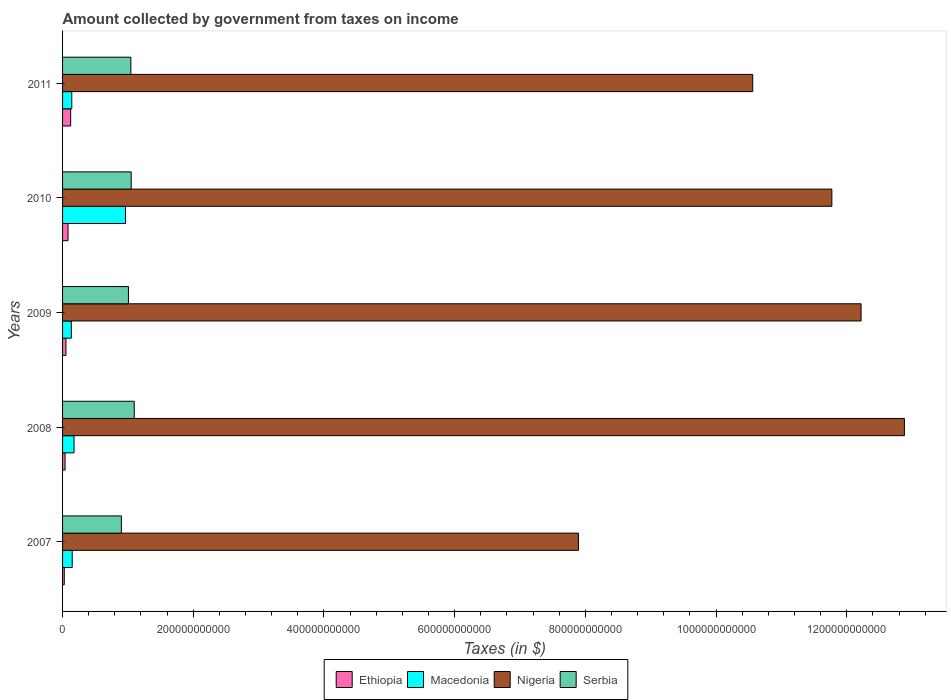How many different coloured bars are there?
Provide a succinct answer. 4. Are the number of bars per tick equal to the number of legend labels?
Your answer should be compact. Yes. How many bars are there on the 3rd tick from the top?
Your answer should be very brief. 4. How many bars are there on the 4th tick from the bottom?
Give a very brief answer. 4. What is the label of the 5th group of bars from the top?
Offer a terse response. 2007. What is the amount collected by government from taxes on income in Macedonia in 2008?
Offer a terse response. 1.76e+1. Across all years, what is the maximum amount collected by government from taxes on income in Macedonia?
Ensure brevity in your answer.  9.63e+1. Across all years, what is the minimum amount collected by government from taxes on income in Macedonia?
Your response must be concise. 1.34e+1. In which year was the amount collected by government from taxes on income in Nigeria maximum?
Your answer should be compact. 2008. In which year was the amount collected by government from taxes on income in Nigeria minimum?
Your response must be concise. 2007. What is the total amount collected by government from taxes on income in Ethiopia in the graph?
Your answer should be very brief. 3.24e+1. What is the difference between the amount collected by government from taxes on income in Nigeria in 2008 and that in 2011?
Make the answer very short. 2.32e+11. What is the difference between the amount collected by government from taxes on income in Macedonia in 2009 and the amount collected by government from taxes on income in Ethiopia in 2008?
Keep it short and to the point. 9.61e+09. What is the average amount collected by government from taxes on income in Nigeria per year?
Your answer should be compact. 1.11e+12. In the year 2010, what is the difference between the amount collected by government from taxes on income in Ethiopia and amount collected by government from taxes on income in Serbia?
Give a very brief answer. -9.67e+1. In how many years, is the amount collected by government from taxes on income in Serbia greater than 920000000000 $?
Ensure brevity in your answer.  0. What is the ratio of the amount collected by government from taxes on income in Macedonia in 2008 to that in 2011?
Offer a very short reply. 1.25. Is the difference between the amount collected by government from taxes on income in Ethiopia in 2009 and 2011 greater than the difference between the amount collected by government from taxes on income in Serbia in 2009 and 2011?
Ensure brevity in your answer.  No. What is the difference between the highest and the second highest amount collected by government from taxes on income in Ethiopia?
Ensure brevity in your answer.  4.06e+09. What is the difference between the highest and the lowest amount collected by government from taxes on income in Macedonia?
Your response must be concise. 8.29e+1. In how many years, is the amount collected by government from taxes on income in Nigeria greater than the average amount collected by government from taxes on income in Nigeria taken over all years?
Offer a very short reply. 3. Is it the case that in every year, the sum of the amount collected by government from taxes on income in Nigeria and amount collected by government from taxes on income in Ethiopia is greater than the sum of amount collected by government from taxes on income in Macedonia and amount collected by government from taxes on income in Serbia?
Your answer should be compact. Yes. What does the 1st bar from the top in 2008 represents?
Your answer should be compact. Serbia. What does the 4th bar from the bottom in 2008 represents?
Provide a succinct answer. Serbia. Is it the case that in every year, the sum of the amount collected by government from taxes on income in Serbia and amount collected by government from taxes on income in Ethiopia is greater than the amount collected by government from taxes on income in Macedonia?
Offer a very short reply. Yes. Are all the bars in the graph horizontal?
Provide a short and direct response. Yes. How many years are there in the graph?
Offer a very short reply. 5. What is the difference between two consecutive major ticks on the X-axis?
Provide a succinct answer. 2.00e+11. Are the values on the major ticks of X-axis written in scientific E-notation?
Provide a short and direct response. No. Does the graph contain any zero values?
Your answer should be compact. No. How are the legend labels stacked?
Your answer should be compact. Horizontal. What is the title of the graph?
Provide a short and direct response. Amount collected by government from taxes on income. Does "Congo (Republic)" appear as one of the legend labels in the graph?
Ensure brevity in your answer.  No. What is the label or title of the X-axis?
Give a very brief answer. Taxes (in $). What is the Taxes (in $) in Ethiopia in 2007?
Provide a short and direct response. 2.64e+09. What is the Taxes (in $) of Macedonia in 2007?
Give a very brief answer. 1.48e+1. What is the Taxes (in $) in Nigeria in 2007?
Your answer should be very brief. 7.89e+11. What is the Taxes (in $) of Serbia in 2007?
Offer a terse response. 9.00e+1. What is the Taxes (in $) of Ethiopia in 2008?
Ensure brevity in your answer.  3.80e+09. What is the Taxes (in $) of Macedonia in 2008?
Offer a terse response. 1.76e+1. What is the Taxes (in $) in Nigeria in 2008?
Make the answer very short. 1.29e+12. What is the Taxes (in $) of Serbia in 2008?
Give a very brief answer. 1.10e+11. What is the Taxes (in $) in Ethiopia in 2009?
Provide a short and direct response. 5.19e+09. What is the Taxes (in $) of Macedonia in 2009?
Provide a succinct answer. 1.34e+1. What is the Taxes (in $) of Nigeria in 2009?
Keep it short and to the point. 1.22e+12. What is the Taxes (in $) in Serbia in 2009?
Your answer should be very brief. 1.01e+11. What is the Taxes (in $) in Ethiopia in 2010?
Your answer should be very brief. 8.35e+09. What is the Taxes (in $) in Macedonia in 2010?
Ensure brevity in your answer.  9.63e+1. What is the Taxes (in $) in Nigeria in 2010?
Give a very brief answer. 1.18e+12. What is the Taxes (in $) in Serbia in 2010?
Offer a terse response. 1.05e+11. What is the Taxes (in $) of Ethiopia in 2011?
Make the answer very short. 1.24e+1. What is the Taxes (in $) in Macedonia in 2011?
Ensure brevity in your answer.  1.41e+1. What is the Taxes (in $) of Nigeria in 2011?
Give a very brief answer. 1.06e+12. What is the Taxes (in $) in Serbia in 2011?
Your answer should be compact. 1.04e+11. Across all years, what is the maximum Taxes (in $) of Ethiopia?
Give a very brief answer. 1.24e+1. Across all years, what is the maximum Taxes (in $) of Macedonia?
Your answer should be compact. 9.63e+1. Across all years, what is the maximum Taxes (in $) of Nigeria?
Your answer should be very brief. 1.29e+12. Across all years, what is the maximum Taxes (in $) of Serbia?
Your answer should be compact. 1.10e+11. Across all years, what is the minimum Taxes (in $) in Ethiopia?
Offer a very short reply. 2.64e+09. Across all years, what is the minimum Taxes (in $) in Macedonia?
Provide a short and direct response. 1.34e+1. Across all years, what is the minimum Taxes (in $) of Nigeria?
Ensure brevity in your answer.  7.89e+11. Across all years, what is the minimum Taxes (in $) of Serbia?
Your answer should be compact. 9.00e+1. What is the total Taxes (in $) of Ethiopia in the graph?
Keep it short and to the point. 3.24e+1. What is the total Taxes (in $) of Macedonia in the graph?
Your response must be concise. 1.56e+11. What is the total Taxes (in $) of Nigeria in the graph?
Make the answer very short. 5.53e+12. What is the total Taxes (in $) in Serbia in the graph?
Offer a very short reply. 5.10e+11. What is the difference between the Taxes (in $) in Ethiopia in 2007 and that in 2008?
Provide a succinct answer. -1.16e+09. What is the difference between the Taxes (in $) of Macedonia in 2007 and that in 2008?
Offer a terse response. -2.81e+09. What is the difference between the Taxes (in $) of Nigeria in 2007 and that in 2008?
Your answer should be compact. -4.99e+11. What is the difference between the Taxes (in $) of Serbia in 2007 and that in 2008?
Provide a short and direct response. -1.97e+1. What is the difference between the Taxes (in $) in Ethiopia in 2007 and that in 2009?
Your answer should be very brief. -2.56e+09. What is the difference between the Taxes (in $) in Macedonia in 2007 and that in 2009?
Your answer should be compact. 1.35e+09. What is the difference between the Taxes (in $) of Nigeria in 2007 and that in 2009?
Offer a very short reply. -4.32e+11. What is the difference between the Taxes (in $) in Serbia in 2007 and that in 2009?
Offer a very short reply. -1.08e+1. What is the difference between the Taxes (in $) of Ethiopia in 2007 and that in 2010?
Make the answer very short. -5.72e+09. What is the difference between the Taxes (in $) of Macedonia in 2007 and that in 2010?
Offer a terse response. -8.15e+1. What is the difference between the Taxes (in $) of Nigeria in 2007 and that in 2010?
Make the answer very short. -3.88e+11. What is the difference between the Taxes (in $) of Serbia in 2007 and that in 2010?
Offer a very short reply. -1.51e+1. What is the difference between the Taxes (in $) in Ethiopia in 2007 and that in 2011?
Give a very brief answer. -9.78e+09. What is the difference between the Taxes (in $) of Macedonia in 2007 and that in 2011?
Provide a short and direct response. 6.55e+08. What is the difference between the Taxes (in $) of Nigeria in 2007 and that in 2011?
Make the answer very short. -2.67e+11. What is the difference between the Taxes (in $) in Serbia in 2007 and that in 2011?
Give a very brief answer. -1.45e+1. What is the difference between the Taxes (in $) of Ethiopia in 2008 and that in 2009?
Make the answer very short. -1.39e+09. What is the difference between the Taxes (in $) in Macedonia in 2008 and that in 2009?
Keep it short and to the point. 4.16e+09. What is the difference between the Taxes (in $) of Nigeria in 2008 and that in 2009?
Provide a succinct answer. 6.63e+1. What is the difference between the Taxes (in $) in Serbia in 2008 and that in 2009?
Give a very brief answer. 8.86e+09. What is the difference between the Taxes (in $) of Ethiopia in 2008 and that in 2010?
Make the answer very short. -4.56e+09. What is the difference between the Taxes (in $) of Macedonia in 2008 and that in 2010?
Provide a short and direct response. -7.87e+1. What is the difference between the Taxes (in $) of Nigeria in 2008 and that in 2010?
Give a very brief answer. 1.11e+11. What is the difference between the Taxes (in $) in Serbia in 2008 and that in 2010?
Offer a very short reply. 4.60e+09. What is the difference between the Taxes (in $) in Ethiopia in 2008 and that in 2011?
Provide a succinct answer. -8.62e+09. What is the difference between the Taxes (in $) in Macedonia in 2008 and that in 2011?
Make the answer very short. 3.46e+09. What is the difference between the Taxes (in $) of Nigeria in 2008 and that in 2011?
Give a very brief answer. 2.32e+11. What is the difference between the Taxes (in $) of Serbia in 2008 and that in 2011?
Give a very brief answer. 5.17e+09. What is the difference between the Taxes (in $) in Ethiopia in 2009 and that in 2010?
Offer a very short reply. -3.16e+09. What is the difference between the Taxes (in $) of Macedonia in 2009 and that in 2010?
Offer a terse response. -8.29e+1. What is the difference between the Taxes (in $) of Nigeria in 2009 and that in 2010?
Provide a succinct answer. 4.47e+1. What is the difference between the Taxes (in $) in Serbia in 2009 and that in 2010?
Provide a short and direct response. -4.26e+09. What is the difference between the Taxes (in $) of Ethiopia in 2009 and that in 2011?
Provide a short and direct response. -7.22e+09. What is the difference between the Taxes (in $) in Macedonia in 2009 and that in 2011?
Provide a short and direct response. -6.92e+08. What is the difference between the Taxes (in $) in Nigeria in 2009 and that in 2011?
Ensure brevity in your answer.  1.66e+11. What is the difference between the Taxes (in $) in Serbia in 2009 and that in 2011?
Give a very brief answer. -3.69e+09. What is the difference between the Taxes (in $) of Ethiopia in 2010 and that in 2011?
Make the answer very short. -4.06e+09. What is the difference between the Taxes (in $) of Macedonia in 2010 and that in 2011?
Offer a terse response. 8.22e+1. What is the difference between the Taxes (in $) in Nigeria in 2010 and that in 2011?
Offer a very short reply. 1.21e+11. What is the difference between the Taxes (in $) of Serbia in 2010 and that in 2011?
Provide a succinct answer. 5.70e+08. What is the difference between the Taxes (in $) of Ethiopia in 2007 and the Taxes (in $) of Macedonia in 2008?
Your answer should be compact. -1.49e+1. What is the difference between the Taxes (in $) of Ethiopia in 2007 and the Taxes (in $) of Nigeria in 2008?
Offer a terse response. -1.29e+12. What is the difference between the Taxes (in $) in Ethiopia in 2007 and the Taxes (in $) in Serbia in 2008?
Give a very brief answer. -1.07e+11. What is the difference between the Taxes (in $) of Macedonia in 2007 and the Taxes (in $) of Nigeria in 2008?
Make the answer very short. -1.27e+12. What is the difference between the Taxes (in $) of Macedonia in 2007 and the Taxes (in $) of Serbia in 2008?
Provide a short and direct response. -9.49e+1. What is the difference between the Taxes (in $) of Nigeria in 2007 and the Taxes (in $) of Serbia in 2008?
Offer a terse response. 6.80e+11. What is the difference between the Taxes (in $) of Ethiopia in 2007 and the Taxes (in $) of Macedonia in 2009?
Keep it short and to the point. -1.08e+1. What is the difference between the Taxes (in $) in Ethiopia in 2007 and the Taxes (in $) in Nigeria in 2009?
Your answer should be compact. -1.22e+12. What is the difference between the Taxes (in $) in Ethiopia in 2007 and the Taxes (in $) in Serbia in 2009?
Give a very brief answer. -9.82e+1. What is the difference between the Taxes (in $) of Macedonia in 2007 and the Taxes (in $) of Nigeria in 2009?
Your answer should be very brief. -1.21e+12. What is the difference between the Taxes (in $) in Macedonia in 2007 and the Taxes (in $) in Serbia in 2009?
Provide a succinct answer. -8.60e+1. What is the difference between the Taxes (in $) of Nigeria in 2007 and the Taxes (in $) of Serbia in 2009?
Ensure brevity in your answer.  6.89e+11. What is the difference between the Taxes (in $) in Ethiopia in 2007 and the Taxes (in $) in Macedonia in 2010?
Your response must be concise. -9.36e+1. What is the difference between the Taxes (in $) in Ethiopia in 2007 and the Taxes (in $) in Nigeria in 2010?
Your answer should be very brief. -1.17e+12. What is the difference between the Taxes (in $) in Ethiopia in 2007 and the Taxes (in $) in Serbia in 2010?
Ensure brevity in your answer.  -1.02e+11. What is the difference between the Taxes (in $) of Macedonia in 2007 and the Taxes (in $) of Nigeria in 2010?
Provide a short and direct response. -1.16e+12. What is the difference between the Taxes (in $) in Macedonia in 2007 and the Taxes (in $) in Serbia in 2010?
Provide a short and direct response. -9.03e+1. What is the difference between the Taxes (in $) of Nigeria in 2007 and the Taxes (in $) of Serbia in 2010?
Keep it short and to the point. 6.84e+11. What is the difference between the Taxes (in $) in Ethiopia in 2007 and the Taxes (in $) in Macedonia in 2011?
Give a very brief answer. -1.15e+1. What is the difference between the Taxes (in $) in Ethiopia in 2007 and the Taxes (in $) in Nigeria in 2011?
Your answer should be compact. -1.05e+12. What is the difference between the Taxes (in $) of Ethiopia in 2007 and the Taxes (in $) of Serbia in 2011?
Offer a terse response. -1.02e+11. What is the difference between the Taxes (in $) in Macedonia in 2007 and the Taxes (in $) in Nigeria in 2011?
Keep it short and to the point. -1.04e+12. What is the difference between the Taxes (in $) in Macedonia in 2007 and the Taxes (in $) in Serbia in 2011?
Offer a terse response. -8.97e+1. What is the difference between the Taxes (in $) in Nigeria in 2007 and the Taxes (in $) in Serbia in 2011?
Offer a terse response. 6.85e+11. What is the difference between the Taxes (in $) in Ethiopia in 2008 and the Taxes (in $) in Macedonia in 2009?
Offer a very short reply. -9.61e+09. What is the difference between the Taxes (in $) in Ethiopia in 2008 and the Taxes (in $) in Nigeria in 2009?
Your answer should be compact. -1.22e+12. What is the difference between the Taxes (in $) in Ethiopia in 2008 and the Taxes (in $) in Serbia in 2009?
Ensure brevity in your answer.  -9.70e+1. What is the difference between the Taxes (in $) in Macedonia in 2008 and the Taxes (in $) in Nigeria in 2009?
Give a very brief answer. -1.20e+12. What is the difference between the Taxes (in $) of Macedonia in 2008 and the Taxes (in $) of Serbia in 2009?
Offer a terse response. -8.32e+1. What is the difference between the Taxes (in $) in Nigeria in 2008 and the Taxes (in $) in Serbia in 2009?
Your answer should be very brief. 1.19e+12. What is the difference between the Taxes (in $) in Ethiopia in 2008 and the Taxes (in $) in Macedonia in 2010?
Your answer should be compact. -9.25e+1. What is the difference between the Taxes (in $) of Ethiopia in 2008 and the Taxes (in $) of Nigeria in 2010?
Your answer should be compact. -1.17e+12. What is the difference between the Taxes (in $) of Ethiopia in 2008 and the Taxes (in $) of Serbia in 2010?
Your answer should be very brief. -1.01e+11. What is the difference between the Taxes (in $) of Macedonia in 2008 and the Taxes (in $) of Nigeria in 2010?
Offer a very short reply. -1.16e+12. What is the difference between the Taxes (in $) of Macedonia in 2008 and the Taxes (in $) of Serbia in 2010?
Ensure brevity in your answer.  -8.75e+1. What is the difference between the Taxes (in $) of Nigeria in 2008 and the Taxes (in $) of Serbia in 2010?
Your response must be concise. 1.18e+12. What is the difference between the Taxes (in $) of Ethiopia in 2008 and the Taxes (in $) of Macedonia in 2011?
Provide a short and direct response. -1.03e+1. What is the difference between the Taxes (in $) of Ethiopia in 2008 and the Taxes (in $) of Nigeria in 2011?
Provide a succinct answer. -1.05e+12. What is the difference between the Taxes (in $) in Ethiopia in 2008 and the Taxes (in $) in Serbia in 2011?
Provide a succinct answer. -1.01e+11. What is the difference between the Taxes (in $) of Macedonia in 2008 and the Taxes (in $) of Nigeria in 2011?
Provide a succinct answer. -1.04e+12. What is the difference between the Taxes (in $) in Macedonia in 2008 and the Taxes (in $) in Serbia in 2011?
Your answer should be very brief. -8.69e+1. What is the difference between the Taxes (in $) in Nigeria in 2008 and the Taxes (in $) in Serbia in 2011?
Offer a terse response. 1.18e+12. What is the difference between the Taxes (in $) of Ethiopia in 2009 and the Taxes (in $) of Macedonia in 2010?
Provide a short and direct response. -9.11e+1. What is the difference between the Taxes (in $) of Ethiopia in 2009 and the Taxes (in $) of Nigeria in 2010?
Your answer should be very brief. -1.17e+12. What is the difference between the Taxes (in $) of Ethiopia in 2009 and the Taxes (in $) of Serbia in 2010?
Keep it short and to the point. -9.99e+1. What is the difference between the Taxes (in $) in Macedonia in 2009 and the Taxes (in $) in Nigeria in 2010?
Ensure brevity in your answer.  -1.16e+12. What is the difference between the Taxes (in $) in Macedonia in 2009 and the Taxes (in $) in Serbia in 2010?
Offer a very short reply. -9.17e+1. What is the difference between the Taxes (in $) in Nigeria in 2009 and the Taxes (in $) in Serbia in 2010?
Ensure brevity in your answer.  1.12e+12. What is the difference between the Taxes (in $) of Ethiopia in 2009 and the Taxes (in $) of Macedonia in 2011?
Offer a very short reply. -8.91e+09. What is the difference between the Taxes (in $) in Ethiopia in 2009 and the Taxes (in $) in Nigeria in 2011?
Your answer should be compact. -1.05e+12. What is the difference between the Taxes (in $) in Ethiopia in 2009 and the Taxes (in $) in Serbia in 2011?
Your answer should be very brief. -9.93e+1. What is the difference between the Taxes (in $) in Macedonia in 2009 and the Taxes (in $) in Nigeria in 2011?
Offer a terse response. -1.04e+12. What is the difference between the Taxes (in $) in Macedonia in 2009 and the Taxes (in $) in Serbia in 2011?
Offer a very short reply. -9.11e+1. What is the difference between the Taxes (in $) of Nigeria in 2009 and the Taxes (in $) of Serbia in 2011?
Make the answer very short. 1.12e+12. What is the difference between the Taxes (in $) of Ethiopia in 2010 and the Taxes (in $) of Macedonia in 2011?
Give a very brief answer. -5.75e+09. What is the difference between the Taxes (in $) of Ethiopia in 2010 and the Taxes (in $) of Nigeria in 2011?
Your response must be concise. -1.05e+12. What is the difference between the Taxes (in $) of Ethiopia in 2010 and the Taxes (in $) of Serbia in 2011?
Provide a short and direct response. -9.61e+1. What is the difference between the Taxes (in $) in Macedonia in 2010 and the Taxes (in $) in Nigeria in 2011?
Give a very brief answer. -9.60e+11. What is the difference between the Taxes (in $) of Macedonia in 2010 and the Taxes (in $) of Serbia in 2011?
Ensure brevity in your answer.  -8.22e+09. What is the difference between the Taxes (in $) of Nigeria in 2010 and the Taxes (in $) of Serbia in 2011?
Your answer should be compact. 1.07e+12. What is the average Taxes (in $) of Ethiopia per year?
Your answer should be compact. 6.48e+09. What is the average Taxes (in $) in Macedonia per year?
Offer a very short reply. 3.12e+1. What is the average Taxes (in $) in Nigeria per year?
Your answer should be very brief. 1.11e+12. What is the average Taxes (in $) in Serbia per year?
Ensure brevity in your answer.  1.02e+11. In the year 2007, what is the difference between the Taxes (in $) of Ethiopia and Taxes (in $) of Macedonia?
Your response must be concise. -1.21e+1. In the year 2007, what is the difference between the Taxes (in $) in Ethiopia and Taxes (in $) in Nigeria?
Offer a terse response. -7.87e+11. In the year 2007, what is the difference between the Taxes (in $) of Ethiopia and Taxes (in $) of Serbia?
Offer a very short reply. -8.73e+1. In the year 2007, what is the difference between the Taxes (in $) in Macedonia and Taxes (in $) in Nigeria?
Your response must be concise. -7.75e+11. In the year 2007, what is the difference between the Taxes (in $) in Macedonia and Taxes (in $) in Serbia?
Your answer should be very brief. -7.52e+1. In the year 2007, what is the difference between the Taxes (in $) in Nigeria and Taxes (in $) in Serbia?
Your answer should be very brief. 6.99e+11. In the year 2008, what is the difference between the Taxes (in $) in Ethiopia and Taxes (in $) in Macedonia?
Your answer should be compact. -1.38e+1. In the year 2008, what is the difference between the Taxes (in $) of Ethiopia and Taxes (in $) of Nigeria?
Provide a short and direct response. -1.28e+12. In the year 2008, what is the difference between the Taxes (in $) of Ethiopia and Taxes (in $) of Serbia?
Make the answer very short. -1.06e+11. In the year 2008, what is the difference between the Taxes (in $) of Macedonia and Taxes (in $) of Nigeria?
Your response must be concise. -1.27e+12. In the year 2008, what is the difference between the Taxes (in $) in Macedonia and Taxes (in $) in Serbia?
Your answer should be very brief. -9.21e+1. In the year 2008, what is the difference between the Taxes (in $) of Nigeria and Taxes (in $) of Serbia?
Ensure brevity in your answer.  1.18e+12. In the year 2009, what is the difference between the Taxes (in $) of Ethiopia and Taxes (in $) of Macedonia?
Offer a very short reply. -8.22e+09. In the year 2009, what is the difference between the Taxes (in $) of Ethiopia and Taxes (in $) of Nigeria?
Give a very brief answer. -1.22e+12. In the year 2009, what is the difference between the Taxes (in $) in Ethiopia and Taxes (in $) in Serbia?
Your answer should be compact. -9.56e+1. In the year 2009, what is the difference between the Taxes (in $) of Macedonia and Taxes (in $) of Nigeria?
Provide a short and direct response. -1.21e+12. In the year 2009, what is the difference between the Taxes (in $) of Macedonia and Taxes (in $) of Serbia?
Keep it short and to the point. -8.74e+1. In the year 2009, what is the difference between the Taxes (in $) of Nigeria and Taxes (in $) of Serbia?
Ensure brevity in your answer.  1.12e+12. In the year 2010, what is the difference between the Taxes (in $) in Ethiopia and Taxes (in $) in Macedonia?
Provide a short and direct response. -8.79e+1. In the year 2010, what is the difference between the Taxes (in $) in Ethiopia and Taxes (in $) in Nigeria?
Provide a succinct answer. -1.17e+12. In the year 2010, what is the difference between the Taxes (in $) in Ethiopia and Taxes (in $) in Serbia?
Offer a terse response. -9.67e+1. In the year 2010, what is the difference between the Taxes (in $) of Macedonia and Taxes (in $) of Nigeria?
Give a very brief answer. -1.08e+12. In the year 2010, what is the difference between the Taxes (in $) in Macedonia and Taxes (in $) in Serbia?
Provide a short and direct response. -8.79e+09. In the year 2010, what is the difference between the Taxes (in $) of Nigeria and Taxes (in $) of Serbia?
Ensure brevity in your answer.  1.07e+12. In the year 2011, what is the difference between the Taxes (in $) of Ethiopia and Taxes (in $) of Macedonia?
Provide a short and direct response. -1.69e+09. In the year 2011, what is the difference between the Taxes (in $) of Ethiopia and Taxes (in $) of Nigeria?
Your answer should be very brief. -1.04e+12. In the year 2011, what is the difference between the Taxes (in $) of Ethiopia and Taxes (in $) of Serbia?
Give a very brief answer. -9.21e+1. In the year 2011, what is the difference between the Taxes (in $) in Macedonia and Taxes (in $) in Nigeria?
Make the answer very short. -1.04e+12. In the year 2011, what is the difference between the Taxes (in $) in Macedonia and Taxes (in $) in Serbia?
Give a very brief answer. -9.04e+1. In the year 2011, what is the difference between the Taxes (in $) of Nigeria and Taxes (in $) of Serbia?
Your answer should be compact. 9.52e+11. What is the ratio of the Taxes (in $) in Ethiopia in 2007 to that in 2008?
Give a very brief answer. 0.69. What is the ratio of the Taxes (in $) of Macedonia in 2007 to that in 2008?
Keep it short and to the point. 0.84. What is the ratio of the Taxes (in $) in Nigeria in 2007 to that in 2008?
Offer a very short reply. 0.61. What is the ratio of the Taxes (in $) in Serbia in 2007 to that in 2008?
Your answer should be very brief. 0.82. What is the ratio of the Taxes (in $) of Ethiopia in 2007 to that in 2009?
Make the answer very short. 0.51. What is the ratio of the Taxes (in $) in Macedonia in 2007 to that in 2009?
Give a very brief answer. 1.1. What is the ratio of the Taxes (in $) of Nigeria in 2007 to that in 2009?
Keep it short and to the point. 0.65. What is the ratio of the Taxes (in $) in Serbia in 2007 to that in 2009?
Provide a succinct answer. 0.89. What is the ratio of the Taxes (in $) of Ethiopia in 2007 to that in 2010?
Give a very brief answer. 0.32. What is the ratio of the Taxes (in $) in Macedonia in 2007 to that in 2010?
Your response must be concise. 0.15. What is the ratio of the Taxes (in $) of Nigeria in 2007 to that in 2010?
Make the answer very short. 0.67. What is the ratio of the Taxes (in $) in Serbia in 2007 to that in 2010?
Offer a terse response. 0.86. What is the ratio of the Taxes (in $) in Ethiopia in 2007 to that in 2011?
Provide a short and direct response. 0.21. What is the ratio of the Taxes (in $) in Macedonia in 2007 to that in 2011?
Give a very brief answer. 1.05. What is the ratio of the Taxes (in $) in Nigeria in 2007 to that in 2011?
Your answer should be very brief. 0.75. What is the ratio of the Taxes (in $) in Serbia in 2007 to that in 2011?
Offer a terse response. 0.86. What is the ratio of the Taxes (in $) of Ethiopia in 2008 to that in 2009?
Keep it short and to the point. 0.73. What is the ratio of the Taxes (in $) in Macedonia in 2008 to that in 2009?
Give a very brief answer. 1.31. What is the ratio of the Taxes (in $) of Nigeria in 2008 to that in 2009?
Provide a succinct answer. 1.05. What is the ratio of the Taxes (in $) of Serbia in 2008 to that in 2009?
Keep it short and to the point. 1.09. What is the ratio of the Taxes (in $) of Ethiopia in 2008 to that in 2010?
Offer a terse response. 0.45. What is the ratio of the Taxes (in $) in Macedonia in 2008 to that in 2010?
Offer a terse response. 0.18. What is the ratio of the Taxes (in $) of Nigeria in 2008 to that in 2010?
Give a very brief answer. 1.09. What is the ratio of the Taxes (in $) of Serbia in 2008 to that in 2010?
Offer a terse response. 1.04. What is the ratio of the Taxes (in $) of Ethiopia in 2008 to that in 2011?
Your answer should be very brief. 0.31. What is the ratio of the Taxes (in $) in Macedonia in 2008 to that in 2011?
Make the answer very short. 1.25. What is the ratio of the Taxes (in $) in Nigeria in 2008 to that in 2011?
Offer a terse response. 1.22. What is the ratio of the Taxes (in $) of Serbia in 2008 to that in 2011?
Provide a short and direct response. 1.05. What is the ratio of the Taxes (in $) of Ethiopia in 2009 to that in 2010?
Make the answer very short. 0.62. What is the ratio of the Taxes (in $) of Macedonia in 2009 to that in 2010?
Give a very brief answer. 0.14. What is the ratio of the Taxes (in $) of Nigeria in 2009 to that in 2010?
Give a very brief answer. 1.04. What is the ratio of the Taxes (in $) in Serbia in 2009 to that in 2010?
Offer a terse response. 0.96. What is the ratio of the Taxes (in $) of Ethiopia in 2009 to that in 2011?
Offer a terse response. 0.42. What is the ratio of the Taxes (in $) in Macedonia in 2009 to that in 2011?
Make the answer very short. 0.95. What is the ratio of the Taxes (in $) of Nigeria in 2009 to that in 2011?
Provide a short and direct response. 1.16. What is the ratio of the Taxes (in $) in Serbia in 2009 to that in 2011?
Your answer should be very brief. 0.96. What is the ratio of the Taxes (in $) of Ethiopia in 2010 to that in 2011?
Provide a succinct answer. 0.67. What is the ratio of the Taxes (in $) in Macedonia in 2010 to that in 2011?
Your answer should be compact. 6.83. What is the ratio of the Taxes (in $) of Nigeria in 2010 to that in 2011?
Your answer should be compact. 1.11. What is the ratio of the Taxes (in $) in Serbia in 2010 to that in 2011?
Provide a short and direct response. 1.01. What is the difference between the highest and the second highest Taxes (in $) in Ethiopia?
Provide a short and direct response. 4.06e+09. What is the difference between the highest and the second highest Taxes (in $) in Macedonia?
Provide a succinct answer. 7.87e+1. What is the difference between the highest and the second highest Taxes (in $) of Nigeria?
Your answer should be compact. 6.63e+1. What is the difference between the highest and the second highest Taxes (in $) in Serbia?
Ensure brevity in your answer.  4.60e+09. What is the difference between the highest and the lowest Taxes (in $) in Ethiopia?
Make the answer very short. 9.78e+09. What is the difference between the highest and the lowest Taxes (in $) in Macedonia?
Your answer should be very brief. 8.29e+1. What is the difference between the highest and the lowest Taxes (in $) of Nigeria?
Give a very brief answer. 4.99e+11. What is the difference between the highest and the lowest Taxes (in $) in Serbia?
Make the answer very short. 1.97e+1. 